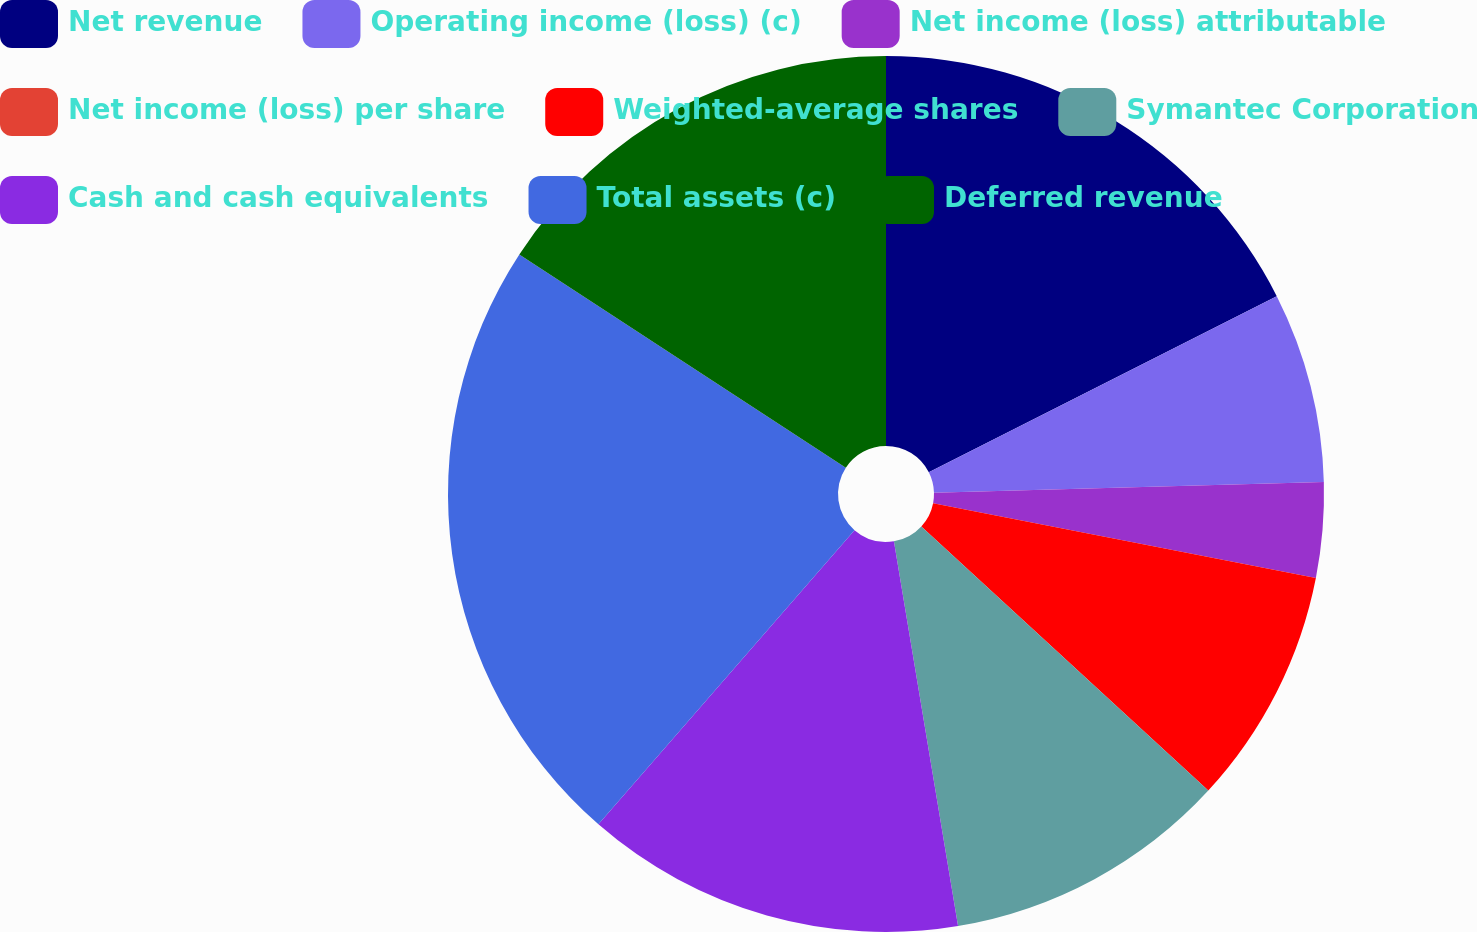Convert chart to OTSL. <chart><loc_0><loc_0><loc_500><loc_500><pie_chart><fcel>Net revenue<fcel>Operating income (loss) (c)<fcel>Net income (loss) attributable<fcel>Net income (loss) per share<fcel>Weighted-average shares<fcel>Symantec Corporation<fcel>Cash and cash equivalents<fcel>Total assets (c)<fcel>Deferred revenue<nl><fcel>17.54%<fcel>7.02%<fcel>3.51%<fcel>0.0%<fcel>8.77%<fcel>10.53%<fcel>14.03%<fcel>22.81%<fcel>15.79%<nl></chart> 